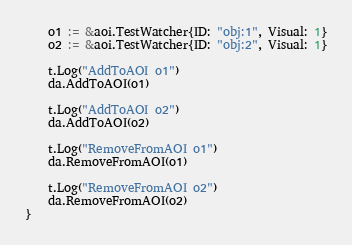<code> <loc_0><loc_0><loc_500><loc_500><_Go_>	o1 := &aoi.TestWatcher{ID: "obj:1", Visual: 1}
	o2 := &aoi.TestWatcher{ID: "obj:2", Visual: 1}

	t.Log("AddToAOI o1")
	da.AddToAOI(o1)

	t.Log("AddToAOI o2")
	da.AddToAOI(o2)

	t.Log("RemoveFromAOI o1")
	da.RemoveFromAOI(o1)

	t.Log("RemoveFromAOI o2")
	da.RemoveFromAOI(o2)
}
</code> 